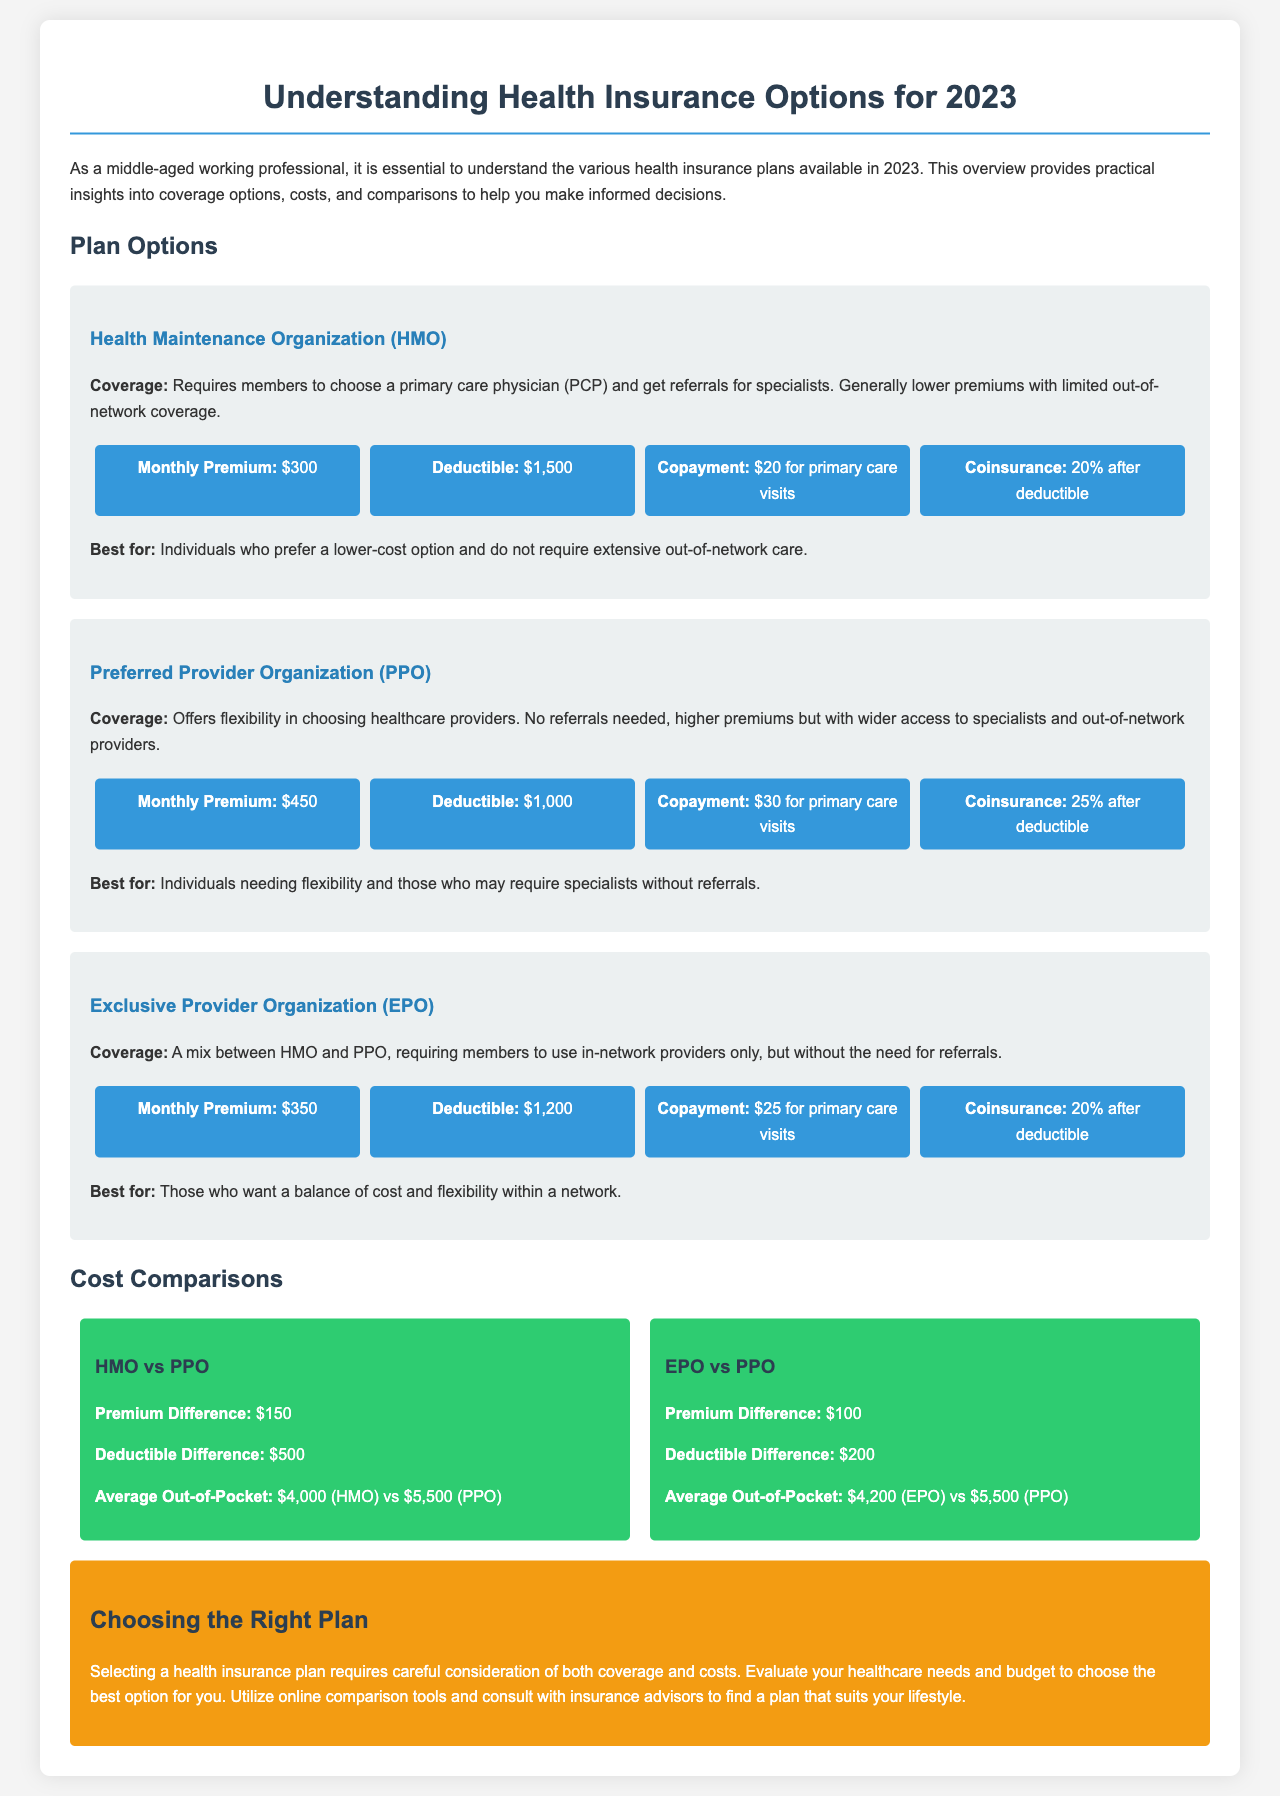What is the monthly premium for HMO? The document specifies the monthly premium for the HMO plan as $300.
Answer: $300 What is the deductible amount for PPO? The document states that the deductible for the PPO plan is $1,000.
Answer: $1,000 What is the copayment for primary care visits under EPO? The document indicates that the copayment for primary care visits under the EPO plan is $25.
Answer: $25 What is the average out-of-pocket cost for HMO? The document mentions that the average out-of-pocket cost for HMO is $4,000.
Answer: $4,000 Which plan has the highest monthly premium? The PPO plan is identified as having the highest monthly premium at $450.
Answer: PPO Which health insurance plan requires referrals for specialists? The HMO plan requires members to get referrals for specialists.
Answer: HMO What is the premium difference between EPO and PPO? The comparison section states that the premium difference between EPO and PPO is $100.
Answer: $100 Which plan is best for individuals needing flexibility? The document lists the PPO as the best plan for individuals needing flexibility.
Answer: PPO What should you evaluate when choosing a health insurance plan? The conclusion advises evaluating healthcare needs and budget when choosing a health insurance plan.
Answer: Healthcare needs and budget 